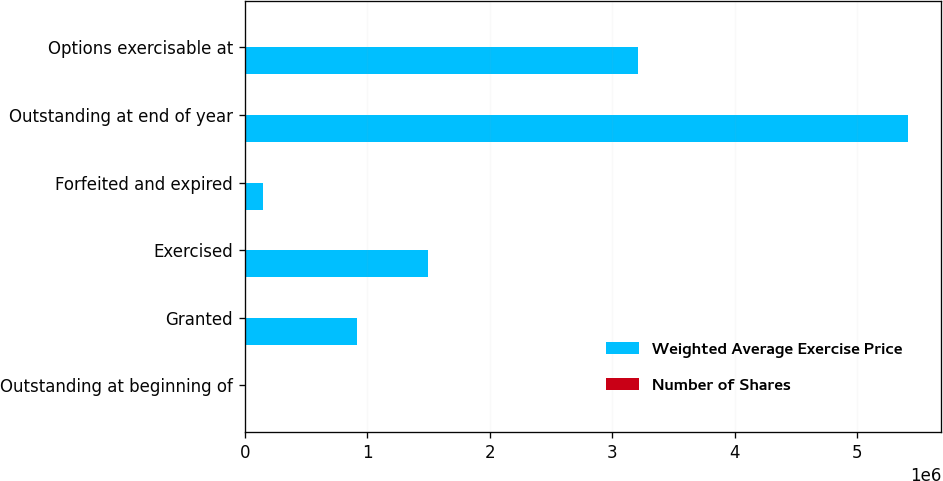Convert chart to OTSL. <chart><loc_0><loc_0><loc_500><loc_500><stacked_bar_chart><ecel><fcel>Outstanding at beginning of<fcel>Granted<fcel>Exercised<fcel>Forfeited and expired<fcel>Outstanding at end of year<fcel>Options exercisable at<nl><fcel>Weighted Average Exercise Price<fcel>55.68<fcel>918343<fcel>1.49469e+06<fcel>151525<fcel>5.4142e+06<fcel>3.21112e+06<nl><fcel>Number of Shares<fcel>42.65<fcel>55.68<fcel>40.38<fcel>51.02<fcel>45.36<fcel>45.5<nl></chart> 